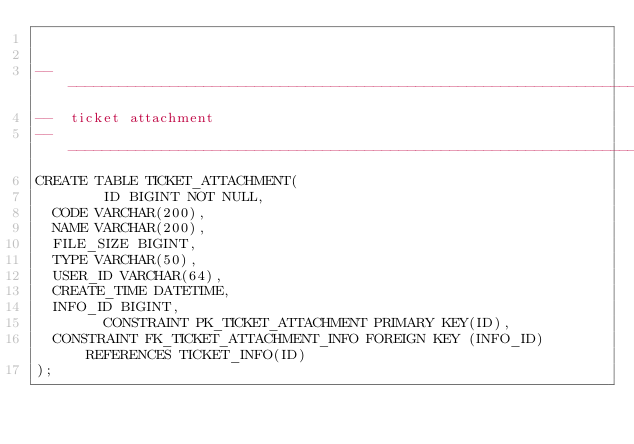<code> <loc_0><loc_0><loc_500><loc_500><_SQL_>

-------------------------------------------------------------------------------
--  ticket attachment
-------------------------------------------------------------------------------
CREATE TABLE TICKET_ATTACHMENT(
        ID BIGINT NOT NULL,
	CODE VARCHAR(200),
	NAME VARCHAR(200),
	FILE_SIZE BIGINT,
	TYPE VARCHAR(50),
	USER_ID VARCHAR(64),
	CREATE_TIME DATETIME,
	INFO_ID BIGINT,
        CONSTRAINT PK_TICKET_ATTACHMENT PRIMARY KEY(ID),
	CONSTRAINT FK_TICKET_ATTACHMENT_INFO FOREIGN KEY (INFO_ID) REFERENCES TICKET_INFO(ID)
);

</code> 